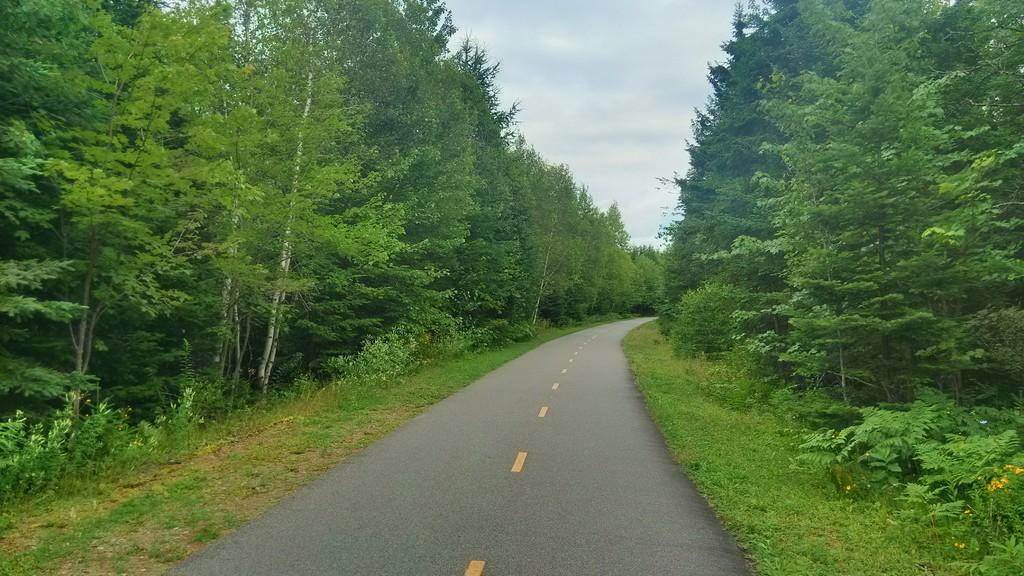What type of vegetation can be seen in the image? There are trees in the image. What can be seen running through the image? There is a road visible in the image. What covers the ground in the image? Grass is present on the ground in the image. How would you describe the sky in the image? The sky is blue and cloudy in the image. What is the name of the person walking on the rail in the image? There is no person walking on a rail in the image; it only features trees, a road, grass, and a blue and cloudy sky. 